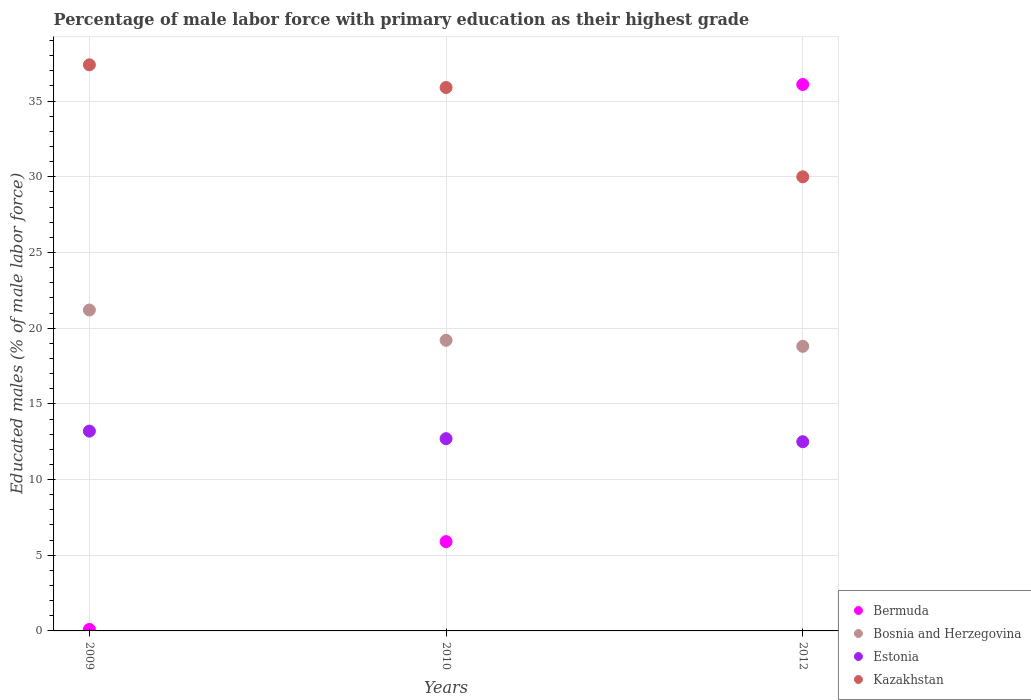How many different coloured dotlines are there?
Give a very brief answer. 4. Is the number of dotlines equal to the number of legend labels?
Offer a terse response. Yes. What is the percentage of male labor force with primary education in Estonia in 2009?
Your answer should be compact. 13.2. Across all years, what is the maximum percentage of male labor force with primary education in Bosnia and Herzegovina?
Provide a succinct answer. 21.2. Across all years, what is the minimum percentage of male labor force with primary education in Estonia?
Your answer should be very brief. 12.5. In which year was the percentage of male labor force with primary education in Estonia maximum?
Provide a short and direct response. 2009. In which year was the percentage of male labor force with primary education in Bosnia and Herzegovina minimum?
Your answer should be compact. 2012. What is the total percentage of male labor force with primary education in Bosnia and Herzegovina in the graph?
Give a very brief answer. 59.2. What is the difference between the percentage of male labor force with primary education in Kazakhstan in 2009 and that in 2010?
Ensure brevity in your answer.  1.5. What is the difference between the percentage of male labor force with primary education in Kazakhstan in 2009 and the percentage of male labor force with primary education in Estonia in 2010?
Offer a terse response. 24.7. What is the average percentage of male labor force with primary education in Bermuda per year?
Provide a short and direct response. 14.03. In the year 2010, what is the difference between the percentage of male labor force with primary education in Kazakhstan and percentage of male labor force with primary education in Bosnia and Herzegovina?
Keep it short and to the point. 16.7. What is the ratio of the percentage of male labor force with primary education in Estonia in 2009 to that in 2010?
Provide a succinct answer. 1.04. Is the percentage of male labor force with primary education in Bosnia and Herzegovina in 2009 less than that in 2012?
Your answer should be compact. No. What is the difference between the highest and the lowest percentage of male labor force with primary education in Estonia?
Keep it short and to the point. 0.7. In how many years, is the percentage of male labor force with primary education in Bosnia and Herzegovina greater than the average percentage of male labor force with primary education in Bosnia and Herzegovina taken over all years?
Give a very brief answer. 1. Is the sum of the percentage of male labor force with primary education in Bermuda in 2009 and 2012 greater than the maximum percentage of male labor force with primary education in Bosnia and Herzegovina across all years?
Your answer should be very brief. Yes. Does the percentage of male labor force with primary education in Estonia monotonically increase over the years?
Your answer should be compact. No. Is the percentage of male labor force with primary education in Estonia strictly greater than the percentage of male labor force with primary education in Kazakhstan over the years?
Give a very brief answer. No. How many dotlines are there?
Offer a terse response. 4. What is the difference between two consecutive major ticks on the Y-axis?
Your answer should be very brief. 5. Are the values on the major ticks of Y-axis written in scientific E-notation?
Provide a succinct answer. No. Does the graph contain any zero values?
Ensure brevity in your answer.  No. What is the title of the graph?
Keep it short and to the point. Percentage of male labor force with primary education as their highest grade. What is the label or title of the Y-axis?
Make the answer very short. Educated males (% of male labor force). What is the Educated males (% of male labor force) in Bermuda in 2009?
Your response must be concise. 0.1. What is the Educated males (% of male labor force) in Bosnia and Herzegovina in 2009?
Provide a succinct answer. 21.2. What is the Educated males (% of male labor force) in Estonia in 2009?
Provide a short and direct response. 13.2. What is the Educated males (% of male labor force) in Kazakhstan in 2009?
Your answer should be compact. 37.4. What is the Educated males (% of male labor force) of Bermuda in 2010?
Provide a short and direct response. 5.9. What is the Educated males (% of male labor force) of Bosnia and Herzegovina in 2010?
Your response must be concise. 19.2. What is the Educated males (% of male labor force) of Estonia in 2010?
Offer a very short reply. 12.7. What is the Educated males (% of male labor force) in Kazakhstan in 2010?
Your answer should be compact. 35.9. What is the Educated males (% of male labor force) of Bermuda in 2012?
Provide a short and direct response. 36.1. What is the Educated males (% of male labor force) of Bosnia and Herzegovina in 2012?
Offer a very short reply. 18.8. What is the Educated males (% of male labor force) in Estonia in 2012?
Provide a short and direct response. 12.5. Across all years, what is the maximum Educated males (% of male labor force) in Bermuda?
Your answer should be very brief. 36.1. Across all years, what is the maximum Educated males (% of male labor force) of Bosnia and Herzegovina?
Keep it short and to the point. 21.2. Across all years, what is the maximum Educated males (% of male labor force) in Estonia?
Your response must be concise. 13.2. Across all years, what is the maximum Educated males (% of male labor force) of Kazakhstan?
Offer a terse response. 37.4. Across all years, what is the minimum Educated males (% of male labor force) in Bermuda?
Give a very brief answer. 0.1. Across all years, what is the minimum Educated males (% of male labor force) in Bosnia and Herzegovina?
Offer a very short reply. 18.8. What is the total Educated males (% of male labor force) of Bermuda in the graph?
Ensure brevity in your answer.  42.1. What is the total Educated males (% of male labor force) of Bosnia and Herzegovina in the graph?
Offer a very short reply. 59.2. What is the total Educated males (% of male labor force) of Estonia in the graph?
Your answer should be compact. 38.4. What is the total Educated males (% of male labor force) in Kazakhstan in the graph?
Your answer should be very brief. 103.3. What is the difference between the Educated males (% of male labor force) of Bermuda in 2009 and that in 2010?
Offer a terse response. -5.8. What is the difference between the Educated males (% of male labor force) in Bosnia and Herzegovina in 2009 and that in 2010?
Make the answer very short. 2. What is the difference between the Educated males (% of male labor force) in Bermuda in 2009 and that in 2012?
Ensure brevity in your answer.  -36. What is the difference between the Educated males (% of male labor force) in Bosnia and Herzegovina in 2009 and that in 2012?
Your answer should be very brief. 2.4. What is the difference between the Educated males (% of male labor force) in Estonia in 2009 and that in 2012?
Your answer should be very brief. 0.7. What is the difference between the Educated males (% of male labor force) in Bermuda in 2010 and that in 2012?
Offer a terse response. -30.2. What is the difference between the Educated males (% of male labor force) in Estonia in 2010 and that in 2012?
Provide a short and direct response. 0.2. What is the difference between the Educated males (% of male labor force) of Bermuda in 2009 and the Educated males (% of male labor force) of Bosnia and Herzegovina in 2010?
Your response must be concise. -19.1. What is the difference between the Educated males (% of male labor force) in Bermuda in 2009 and the Educated males (% of male labor force) in Estonia in 2010?
Provide a short and direct response. -12.6. What is the difference between the Educated males (% of male labor force) of Bermuda in 2009 and the Educated males (% of male labor force) of Kazakhstan in 2010?
Keep it short and to the point. -35.8. What is the difference between the Educated males (% of male labor force) of Bosnia and Herzegovina in 2009 and the Educated males (% of male labor force) of Estonia in 2010?
Make the answer very short. 8.5. What is the difference between the Educated males (% of male labor force) of Bosnia and Herzegovina in 2009 and the Educated males (% of male labor force) of Kazakhstan in 2010?
Offer a very short reply. -14.7. What is the difference between the Educated males (% of male labor force) in Estonia in 2009 and the Educated males (% of male labor force) in Kazakhstan in 2010?
Keep it short and to the point. -22.7. What is the difference between the Educated males (% of male labor force) in Bermuda in 2009 and the Educated males (% of male labor force) in Bosnia and Herzegovina in 2012?
Give a very brief answer. -18.7. What is the difference between the Educated males (% of male labor force) of Bermuda in 2009 and the Educated males (% of male labor force) of Estonia in 2012?
Give a very brief answer. -12.4. What is the difference between the Educated males (% of male labor force) of Bermuda in 2009 and the Educated males (% of male labor force) of Kazakhstan in 2012?
Provide a short and direct response. -29.9. What is the difference between the Educated males (% of male labor force) of Estonia in 2009 and the Educated males (% of male labor force) of Kazakhstan in 2012?
Your answer should be compact. -16.8. What is the difference between the Educated males (% of male labor force) of Bermuda in 2010 and the Educated males (% of male labor force) of Estonia in 2012?
Keep it short and to the point. -6.6. What is the difference between the Educated males (% of male labor force) in Bermuda in 2010 and the Educated males (% of male labor force) in Kazakhstan in 2012?
Offer a terse response. -24.1. What is the difference between the Educated males (% of male labor force) of Bosnia and Herzegovina in 2010 and the Educated males (% of male labor force) of Estonia in 2012?
Your answer should be compact. 6.7. What is the difference between the Educated males (% of male labor force) in Bosnia and Herzegovina in 2010 and the Educated males (% of male labor force) in Kazakhstan in 2012?
Ensure brevity in your answer.  -10.8. What is the difference between the Educated males (% of male labor force) of Estonia in 2010 and the Educated males (% of male labor force) of Kazakhstan in 2012?
Give a very brief answer. -17.3. What is the average Educated males (% of male labor force) of Bermuda per year?
Offer a very short reply. 14.03. What is the average Educated males (% of male labor force) in Bosnia and Herzegovina per year?
Your answer should be very brief. 19.73. What is the average Educated males (% of male labor force) of Estonia per year?
Your answer should be compact. 12.8. What is the average Educated males (% of male labor force) in Kazakhstan per year?
Your answer should be very brief. 34.43. In the year 2009, what is the difference between the Educated males (% of male labor force) in Bermuda and Educated males (% of male labor force) in Bosnia and Herzegovina?
Your answer should be compact. -21.1. In the year 2009, what is the difference between the Educated males (% of male labor force) of Bermuda and Educated males (% of male labor force) of Kazakhstan?
Ensure brevity in your answer.  -37.3. In the year 2009, what is the difference between the Educated males (% of male labor force) in Bosnia and Herzegovina and Educated males (% of male labor force) in Estonia?
Give a very brief answer. 8. In the year 2009, what is the difference between the Educated males (% of male labor force) of Bosnia and Herzegovina and Educated males (% of male labor force) of Kazakhstan?
Your response must be concise. -16.2. In the year 2009, what is the difference between the Educated males (% of male labor force) of Estonia and Educated males (% of male labor force) of Kazakhstan?
Make the answer very short. -24.2. In the year 2010, what is the difference between the Educated males (% of male labor force) in Bermuda and Educated males (% of male labor force) in Bosnia and Herzegovina?
Provide a short and direct response. -13.3. In the year 2010, what is the difference between the Educated males (% of male labor force) of Bermuda and Educated males (% of male labor force) of Estonia?
Make the answer very short. -6.8. In the year 2010, what is the difference between the Educated males (% of male labor force) in Bosnia and Herzegovina and Educated males (% of male labor force) in Kazakhstan?
Keep it short and to the point. -16.7. In the year 2010, what is the difference between the Educated males (% of male labor force) in Estonia and Educated males (% of male labor force) in Kazakhstan?
Provide a short and direct response. -23.2. In the year 2012, what is the difference between the Educated males (% of male labor force) in Bermuda and Educated males (% of male labor force) in Bosnia and Herzegovina?
Provide a succinct answer. 17.3. In the year 2012, what is the difference between the Educated males (% of male labor force) in Bermuda and Educated males (% of male labor force) in Estonia?
Your response must be concise. 23.6. In the year 2012, what is the difference between the Educated males (% of male labor force) of Bosnia and Herzegovina and Educated males (% of male labor force) of Kazakhstan?
Offer a terse response. -11.2. In the year 2012, what is the difference between the Educated males (% of male labor force) of Estonia and Educated males (% of male labor force) of Kazakhstan?
Your answer should be very brief. -17.5. What is the ratio of the Educated males (% of male labor force) of Bermuda in 2009 to that in 2010?
Ensure brevity in your answer.  0.02. What is the ratio of the Educated males (% of male labor force) of Bosnia and Herzegovina in 2009 to that in 2010?
Give a very brief answer. 1.1. What is the ratio of the Educated males (% of male labor force) in Estonia in 2009 to that in 2010?
Keep it short and to the point. 1.04. What is the ratio of the Educated males (% of male labor force) of Kazakhstan in 2009 to that in 2010?
Provide a succinct answer. 1.04. What is the ratio of the Educated males (% of male labor force) of Bermuda in 2009 to that in 2012?
Your answer should be very brief. 0. What is the ratio of the Educated males (% of male labor force) of Bosnia and Herzegovina in 2009 to that in 2012?
Offer a terse response. 1.13. What is the ratio of the Educated males (% of male labor force) in Estonia in 2009 to that in 2012?
Give a very brief answer. 1.06. What is the ratio of the Educated males (% of male labor force) in Kazakhstan in 2009 to that in 2012?
Offer a terse response. 1.25. What is the ratio of the Educated males (% of male labor force) in Bermuda in 2010 to that in 2012?
Ensure brevity in your answer.  0.16. What is the ratio of the Educated males (% of male labor force) in Bosnia and Herzegovina in 2010 to that in 2012?
Your answer should be very brief. 1.02. What is the ratio of the Educated males (% of male labor force) of Kazakhstan in 2010 to that in 2012?
Offer a very short reply. 1.2. What is the difference between the highest and the second highest Educated males (% of male labor force) of Bermuda?
Offer a terse response. 30.2. What is the difference between the highest and the second highest Educated males (% of male labor force) in Kazakhstan?
Make the answer very short. 1.5. What is the difference between the highest and the lowest Educated males (% of male labor force) of Bosnia and Herzegovina?
Ensure brevity in your answer.  2.4. 